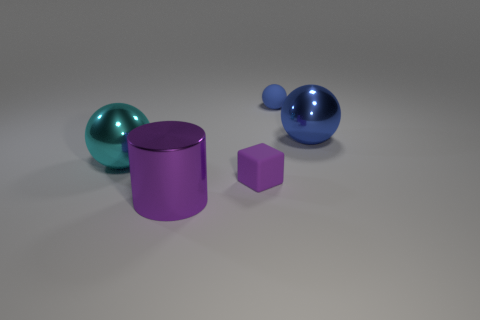Add 2 small blue rubber things. How many objects exist? 7 Subtract all spheres. How many objects are left? 2 Subtract 2 blue spheres. How many objects are left? 3 Subtract all tiny gray objects. Subtract all matte blocks. How many objects are left? 4 Add 3 small purple cubes. How many small purple cubes are left? 4 Add 3 tiny yellow things. How many tiny yellow things exist? 3 